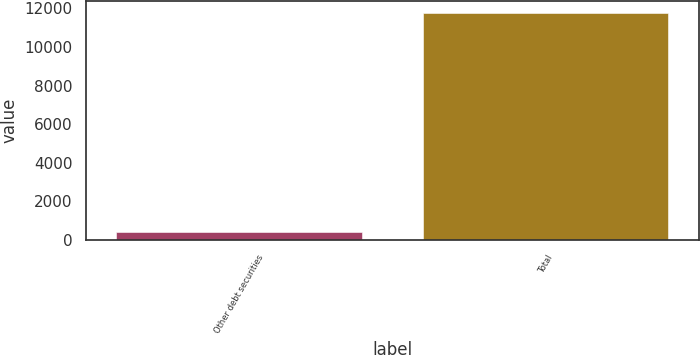Convert chart to OTSL. <chart><loc_0><loc_0><loc_500><loc_500><bar_chart><fcel>Other debt securities<fcel>Total<nl><fcel>423<fcel>11764<nl></chart> 